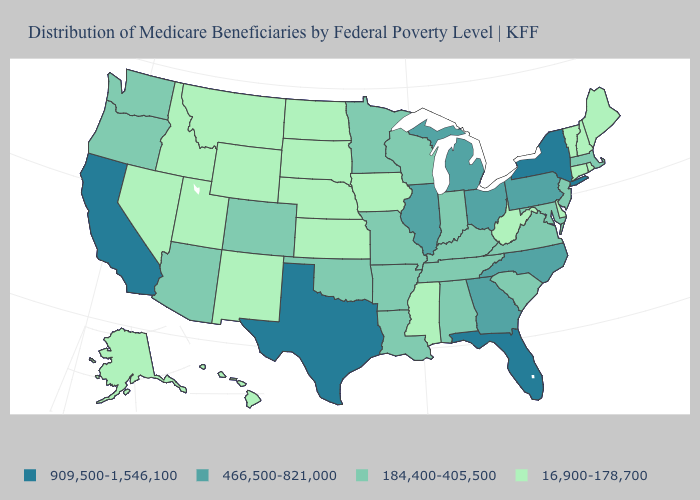Which states have the highest value in the USA?
Concise answer only. California, Florida, New York, Texas. Which states have the highest value in the USA?
Give a very brief answer. California, Florida, New York, Texas. Does New Jersey have the same value as Virginia?
Be succinct. Yes. What is the value of Utah?
Keep it brief. 16,900-178,700. Among the states that border Rhode Island , which have the highest value?
Write a very short answer. Massachusetts. What is the value of New Mexico?
Concise answer only. 16,900-178,700. Among the states that border Indiana , which have the lowest value?
Answer briefly. Kentucky. What is the value of Texas?
Write a very short answer. 909,500-1,546,100. Name the states that have a value in the range 184,400-405,500?
Give a very brief answer. Alabama, Arizona, Arkansas, Colorado, Indiana, Kentucky, Louisiana, Maryland, Massachusetts, Minnesota, Missouri, New Jersey, Oklahoma, Oregon, South Carolina, Tennessee, Virginia, Washington, Wisconsin. Among the states that border Massachusetts , which have the lowest value?
Short answer required. Connecticut, New Hampshire, Rhode Island, Vermont. Among the states that border Montana , which have the lowest value?
Quick response, please. Idaho, North Dakota, South Dakota, Wyoming. Does the first symbol in the legend represent the smallest category?
Quick response, please. No. Among the states that border Kentucky , does Missouri have the highest value?
Write a very short answer. No. What is the value of Virginia?
Keep it brief. 184,400-405,500. What is the highest value in states that border Montana?
Be succinct. 16,900-178,700. 